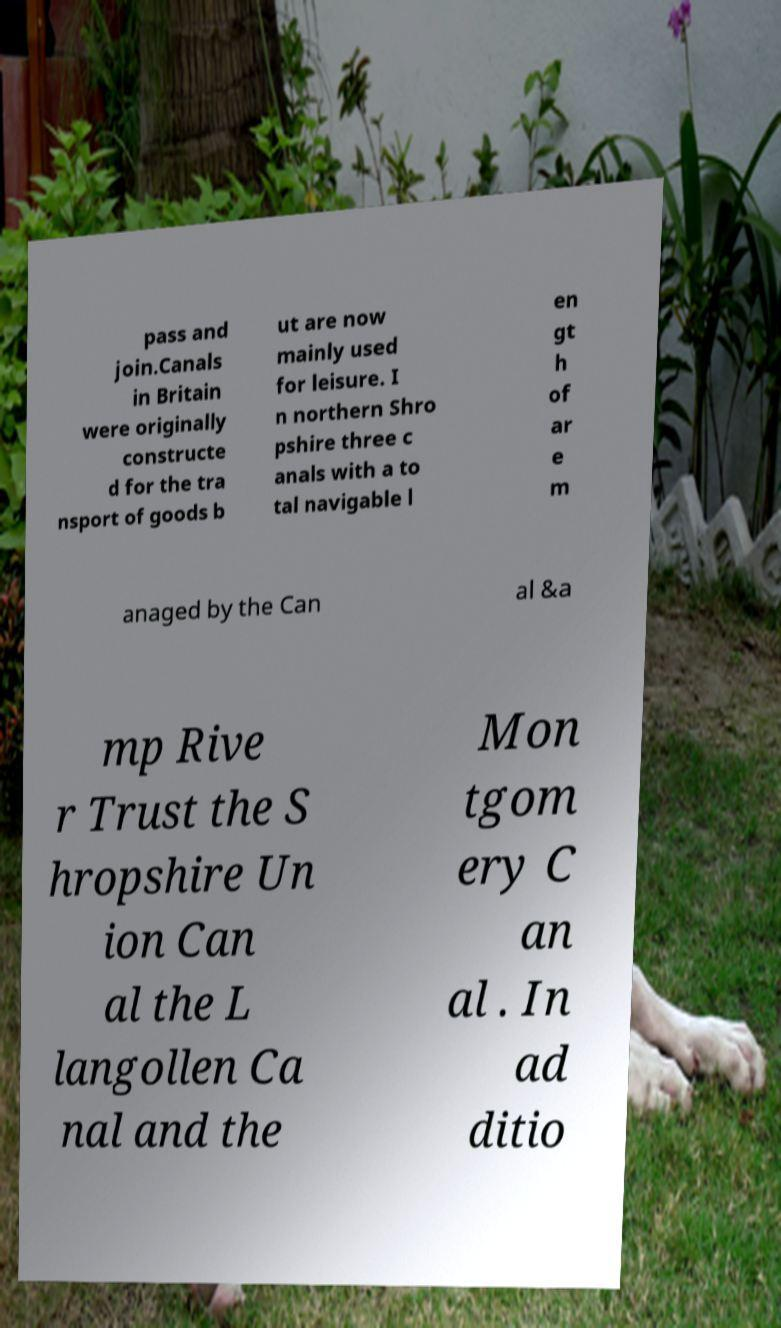Could you assist in decoding the text presented in this image and type it out clearly? pass and join.Canals in Britain were originally constructe d for the tra nsport of goods b ut are now mainly used for leisure. I n northern Shro pshire three c anals with a to tal navigable l en gt h of ar e m anaged by the Can al &a mp Rive r Trust the S hropshire Un ion Can al the L langollen Ca nal and the Mon tgom ery C an al . In ad ditio 